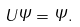Convert formula to latex. <formula><loc_0><loc_0><loc_500><loc_500>U \Psi = \Psi .</formula> 